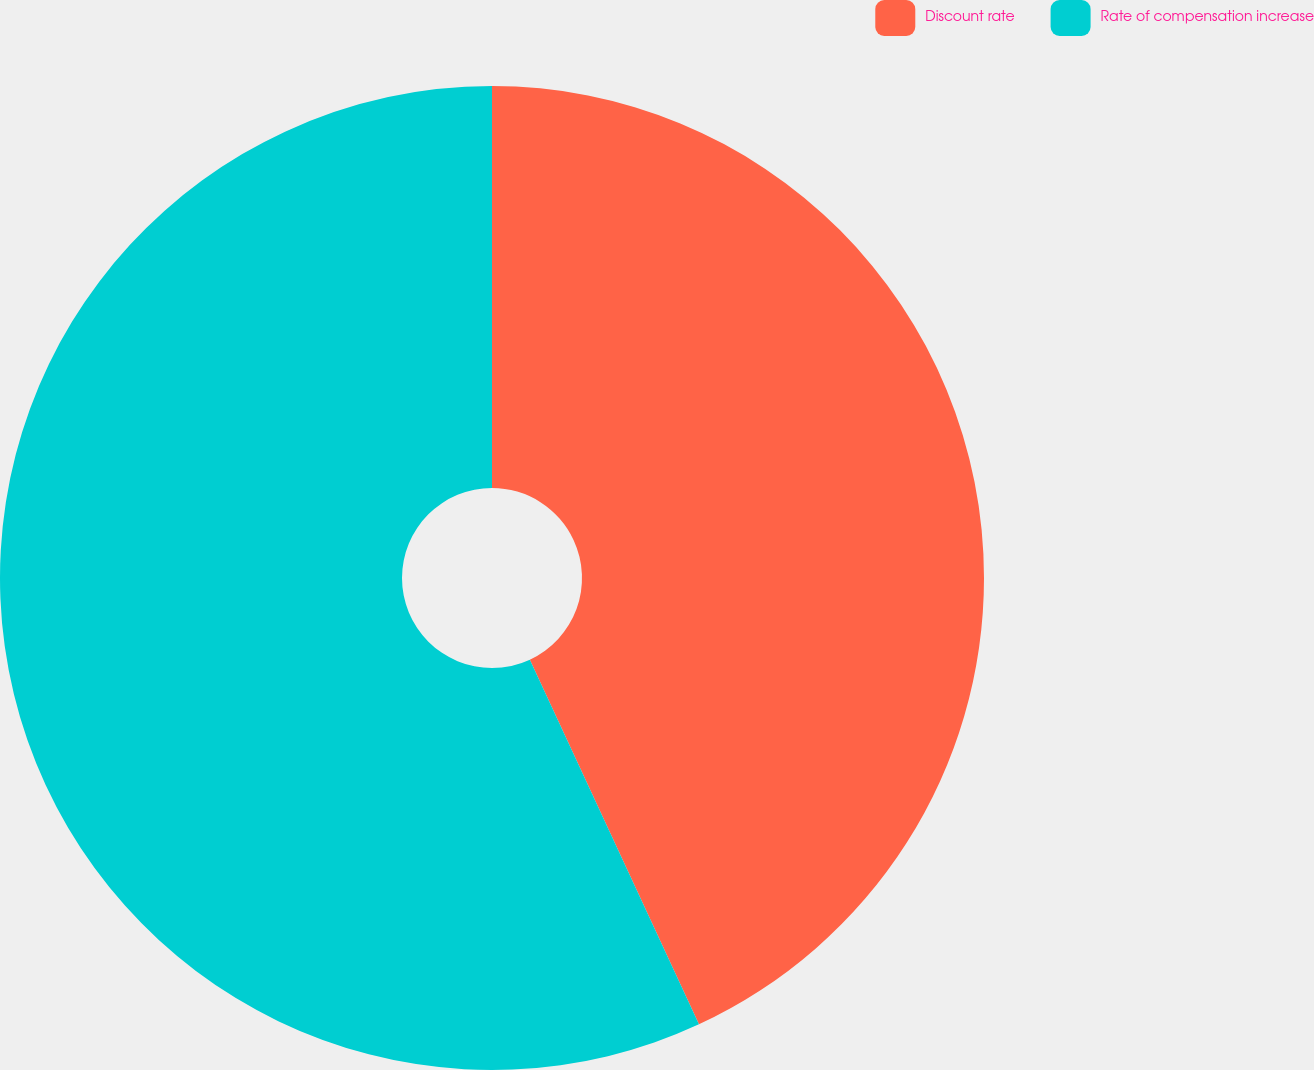<chart> <loc_0><loc_0><loc_500><loc_500><pie_chart><fcel>Discount rate<fcel>Rate of compensation increase<nl><fcel>43.09%<fcel>56.91%<nl></chart> 